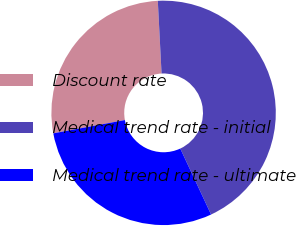<chart> <loc_0><loc_0><loc_500><loc_500><pie_chart><fcel>Discount rate<fcel>Medical trend rate - initial<fcel>Medical trend rate - ultimate<nl><fcel>27.1%<fcel>43.87%<fcel>29.03%<nl></chart> 